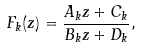<formula> <loc_0><loc_0><loc_500><loc_500>F _ { k } ( z ) = \frac { A _ { k } z + C _ { k } } { B _ { k } z + D _ { k } } ,</formula> 